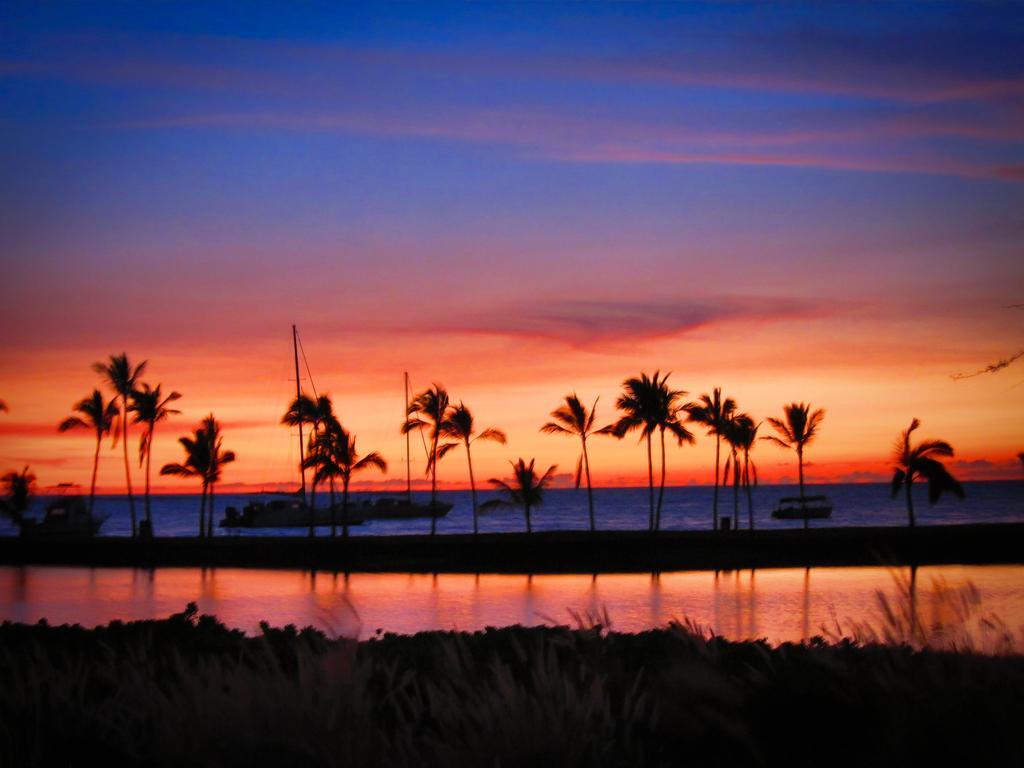Please provide a concise description of this image. In this picture we can see trees, grass, here we can see boats on water and we can see sky in the background. 